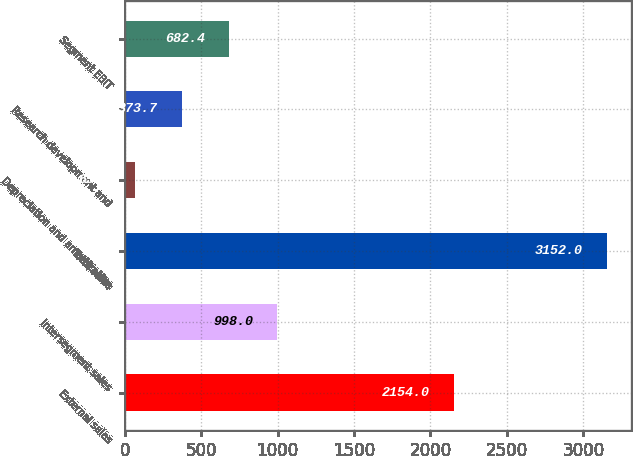<chart> <loc_0><loc_0><loc_500><loc_500><bar_chart><fcel>External sales<fcel>Intersegment sales<fcel>Total sales<fcel>Depreciation and amortization<fcel>Research development and<fcel>Segment EBIT<nl><fcel>2154<fcel>998<fcel>3152<fcel>65<fcel>373.7<fcel>682.4<nl></chart> 